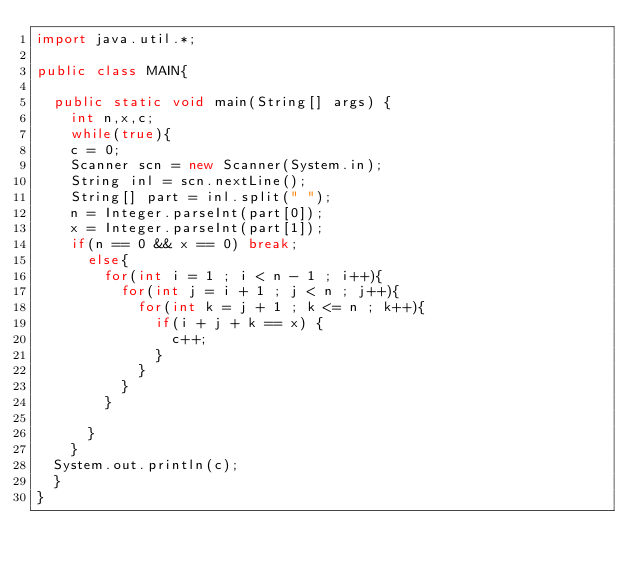<code> <loc_0><loc_0><loc_500><loc_500><_Java_>import java.util.*;

public class MAIN{

	public static void main(String[] args) {
		int n,x,c;
		while(true){
		c = 0;	
		Scanner scn = new Scanner(System.in);
		String inl = scn.nextLine();
		String[] part = inl.split(" ");
		n = Integer.parseInt(part[0]);
		x = Integer.parseInt(part[1]);
		if(n == 0 && x == 0) break;
			else{
				for(int i = 1 ; i < n - 1 ; i++){
					for(int j = i + 1 ; j < n ; j++){
						for(int k = j + 1 ; k <= n ; k++){
							if(i + j + k == x) {
								c++;
							}
						}
					}
				}
			
			}
		}
	System.out.println(c);
	}
}</code> 